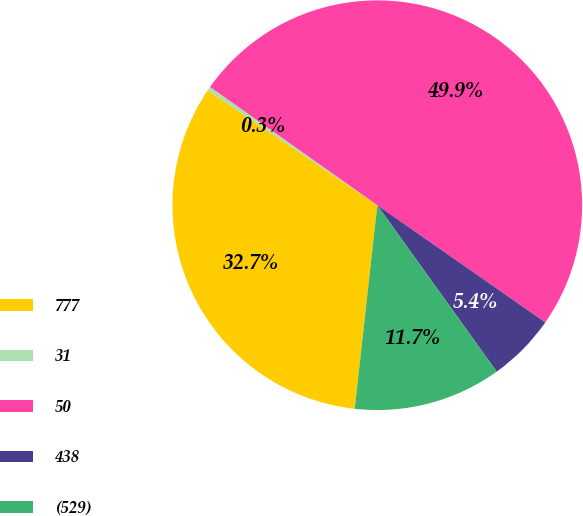Convert chart to OTSL. <chart><loc_0><loc_0><loc_500><loc_500><pie_chart><fcel>777<fcel>31<fcel>50<fcel>438<fcel>(529)<nl><fcel>32.72%<fcel>0.32%<fcel>49.89%<fcel>5.4%<fcel>11.66%<nl></chart> 